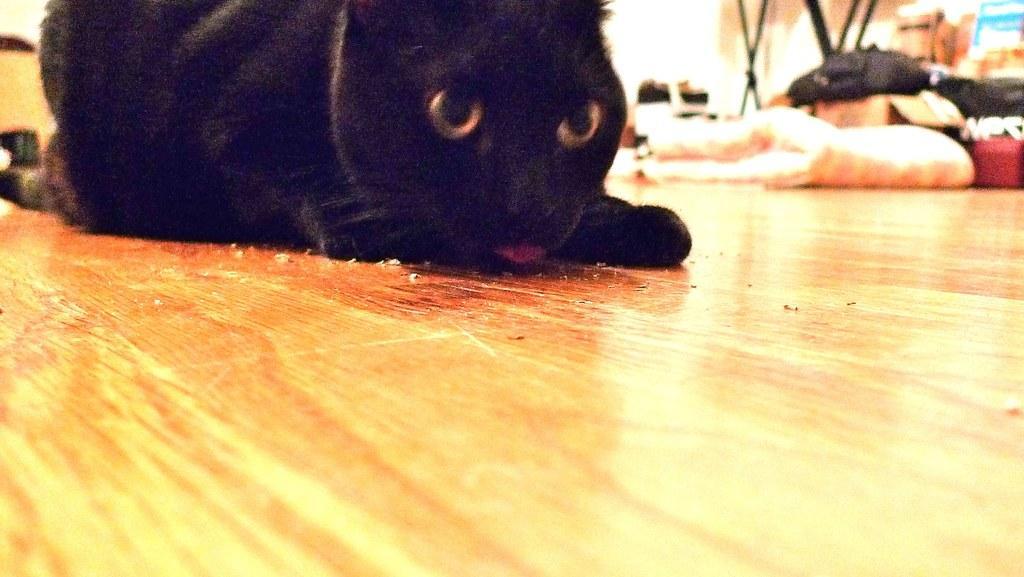Could you give a brief overview of what you see in this image? In the foreground of this image, there is a black color cat on the wooden surface. In the background, there is a bag, cardboard box and few more objects at the top. 